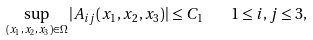<formula> <loc_0><loc_0><loc_500><loc_500>\sup _ { ( x _ { 1 } , x _ { 2 } , x _ { 3 } ) \in \Omega } | A _ { i j } ( x _ { 1 } , x _ { 2 } , x _ { 3 } ) | \leq C _ { 1 } \quad 1 \leq i , j \leq 3 ,</formula> 